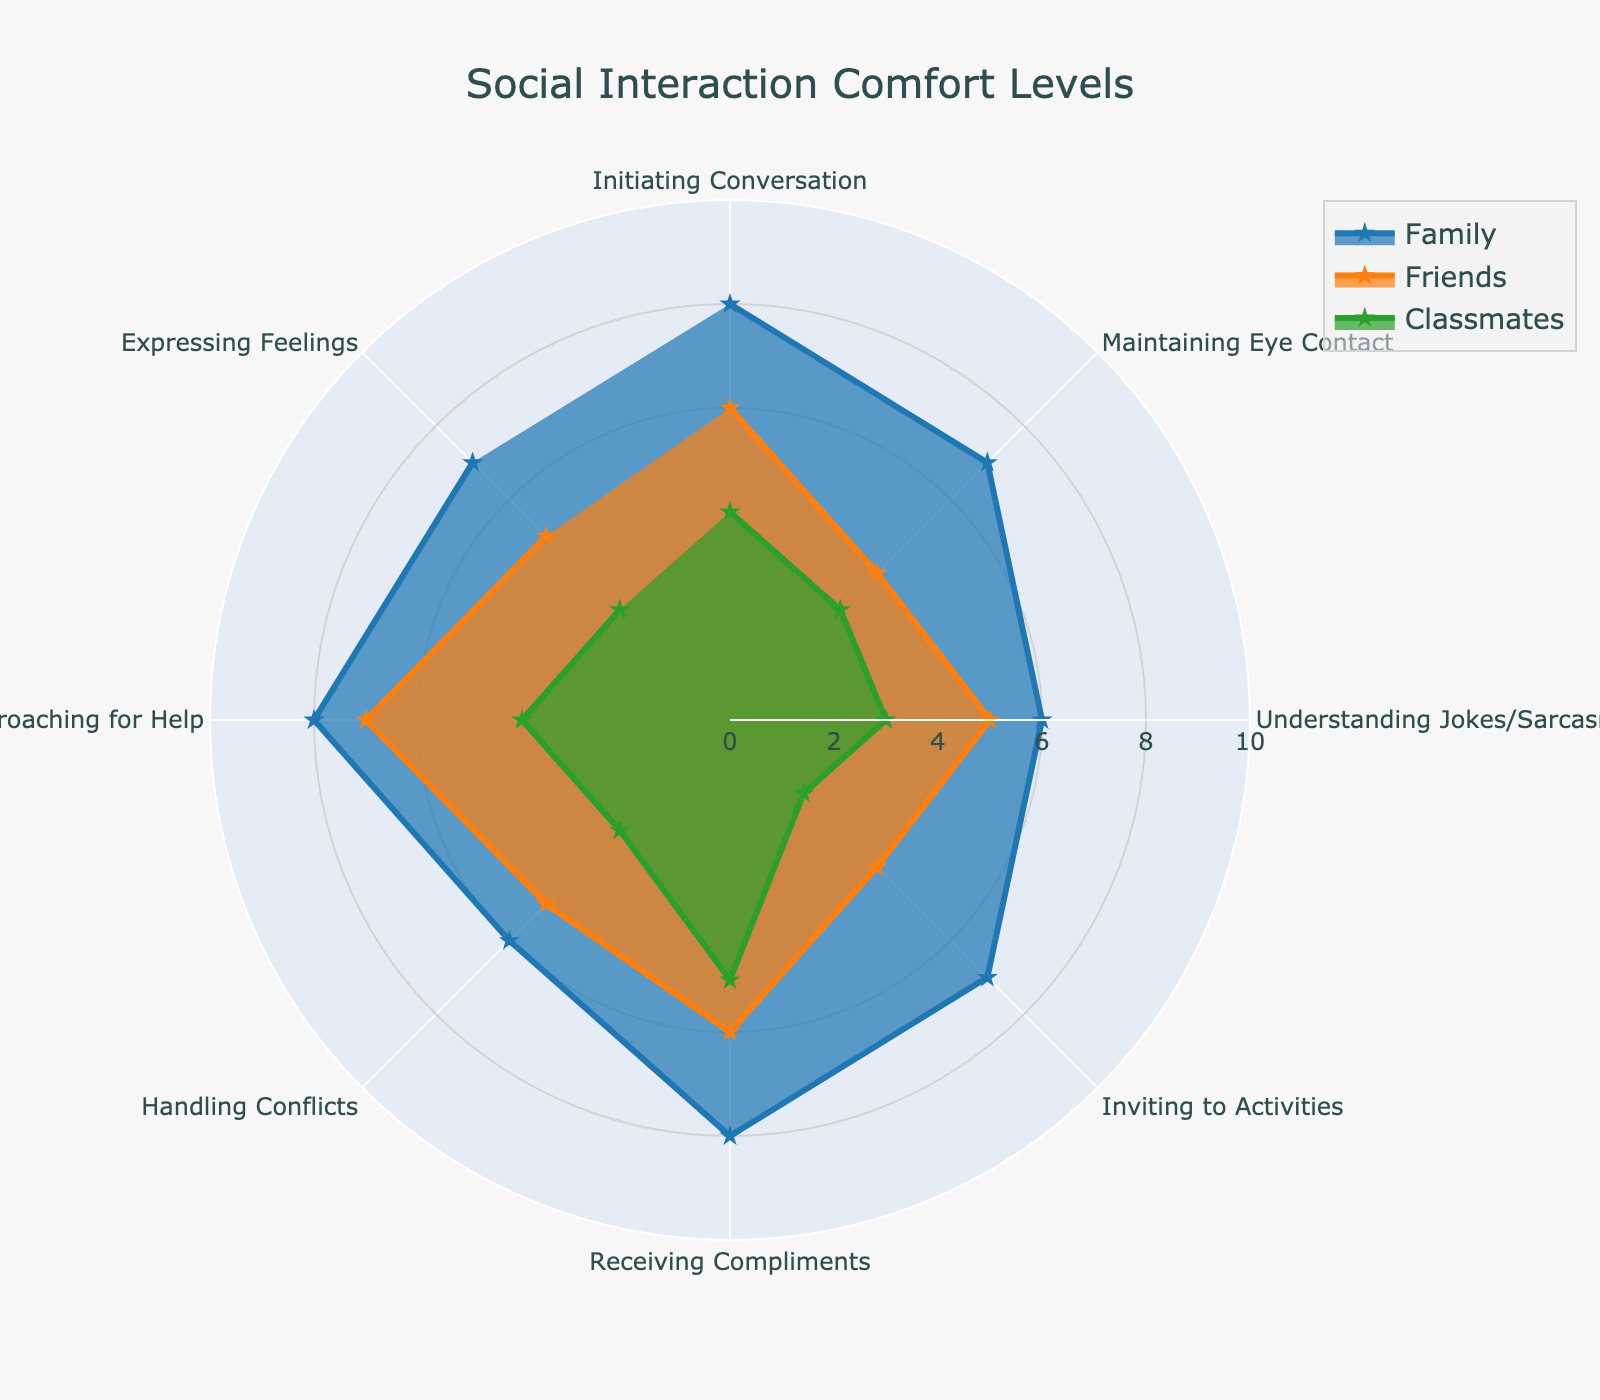What is the title of the radar chart? The title is located at the top center of the chart and provides a summary of what the data is about.
Answer: Social Interaction Comfort Levels How many radial axes (or categories) are displayed in the chart? Count the number of different activities listed around the radar chart.
Answer: Eight What is the color used to represent the "Family" group? Observe the filled shapes and lines in the radar chart and identify which color is associated with the "Family" group, noting it is blue in this case.
Answer: Blue Which group has the highest comfort level for "Approaching for Help"? Compare the "Approaching for Help" values among the "Family," "Friends," and "Classmates" groups in the radar chart.
Answer: Family Are the "Family" and "Friends" groups equally comfortable in "Receiving Compliments"? Check the values for "Receiving Compliments" for both "Family" and "Friends" in the radar chart.
Answer: No What is the average comfort level of the "Classmates" group across all categories? Sum all the values for the "Classmates" group and divide by the number of categories (8). Calculation: (4 + 3 + 3 + 2 + 5 + 3 + 4 + 3) / 8 = 3.375
Answer: 3.375 In which category do "Family" and "Friends" show the biggest difference in comfort levels? Calculate the differences in comfort levels between "Family" and "Friends" for each category and find the maximum difference. Calculation shows the largest difference in "Inviting to Activities" which is 7 - 4 = 3.
Answer: Inviting to Activities Which group appears to have the least variability in comfort levels across the categories? Assess the range of scores (difference between the highest and lowest values) for each group. "Family" has the smallest range.
Answer: Family If we were to calculate the total comfort scores for each group, which group would have the highest total? Sum the comfort levels for each group across all categories and compare. "Family" has the highest total score. Calculation: Family: 8+7+6+7+8+6+8+7 = 57, Friends: 6+4+5+4+6+5+7+5 = 42, Classmates: 4+3+3+2+5+3+4+3 = 27
Answer: Family 